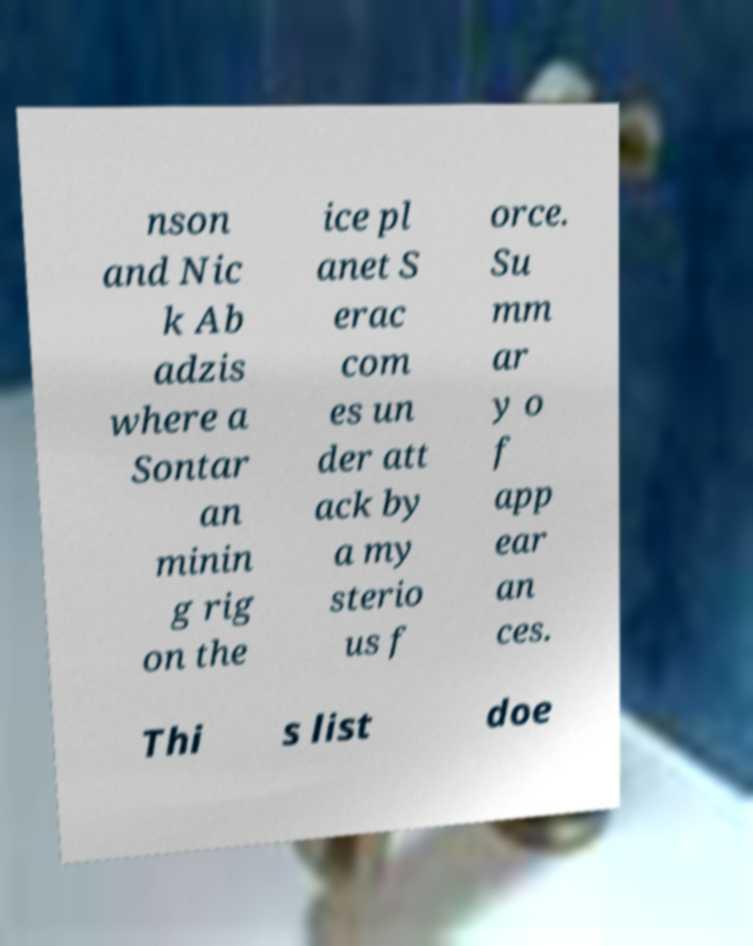Could you assist in decoding the text presented in this image and type it out clearly? nson and Nic k Ab adzis where a Sontar an minin g rig on the ice pl anet S erac com es un der att ack by a my sterio us f orce. Su mm ar y o f app ear an ces. Thi s list doe 